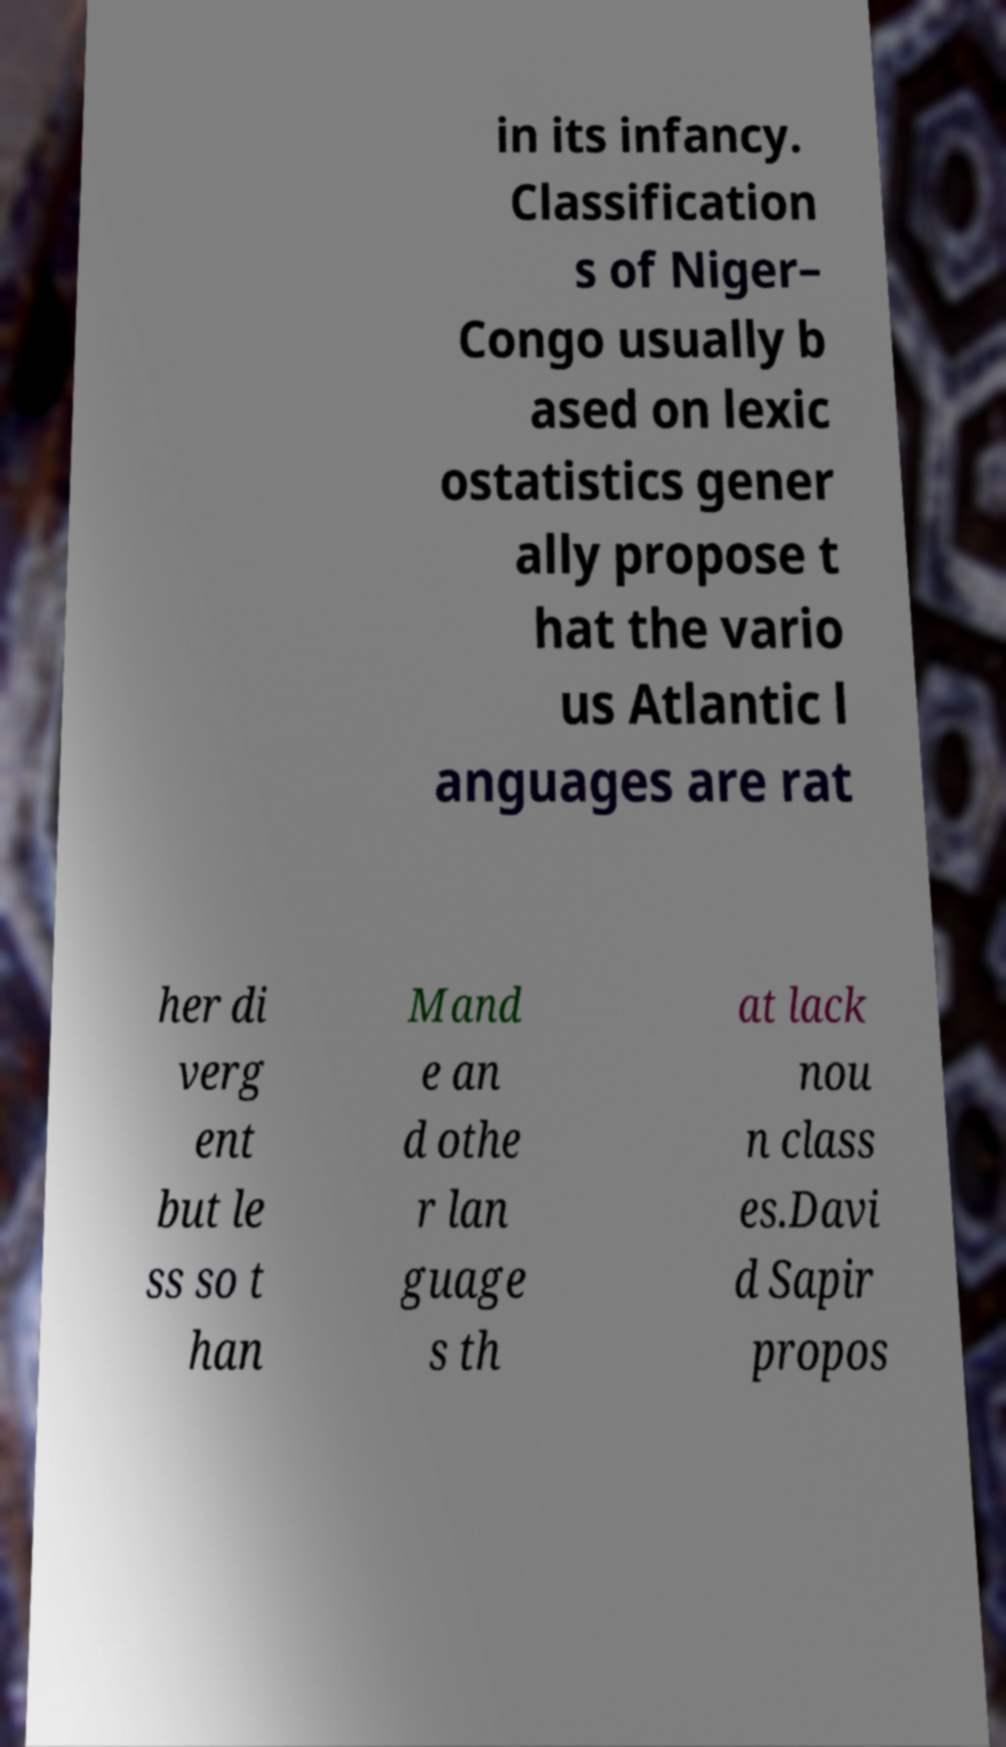What messages or text are displayed in this image? I need them in a readable, typed format. in its infancy. Classification s of Niger– Congo usually b ased on lexic ostatistics gener ally propose t hat the vario us Atlantic l anguages are rat her di verg ent but le ss so t han Mand e an d othe r lan guage s th at lack nou n class es.Davi d Sapir propos 